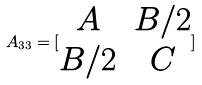Convert formula to latex. <formula><loc_0><loc_0><loc_500><loc_500>A _ { 3 3 } = [ \begin{matrix} A & B / 2 \\ B / 2 & C \end{matrix} ]</formula> 